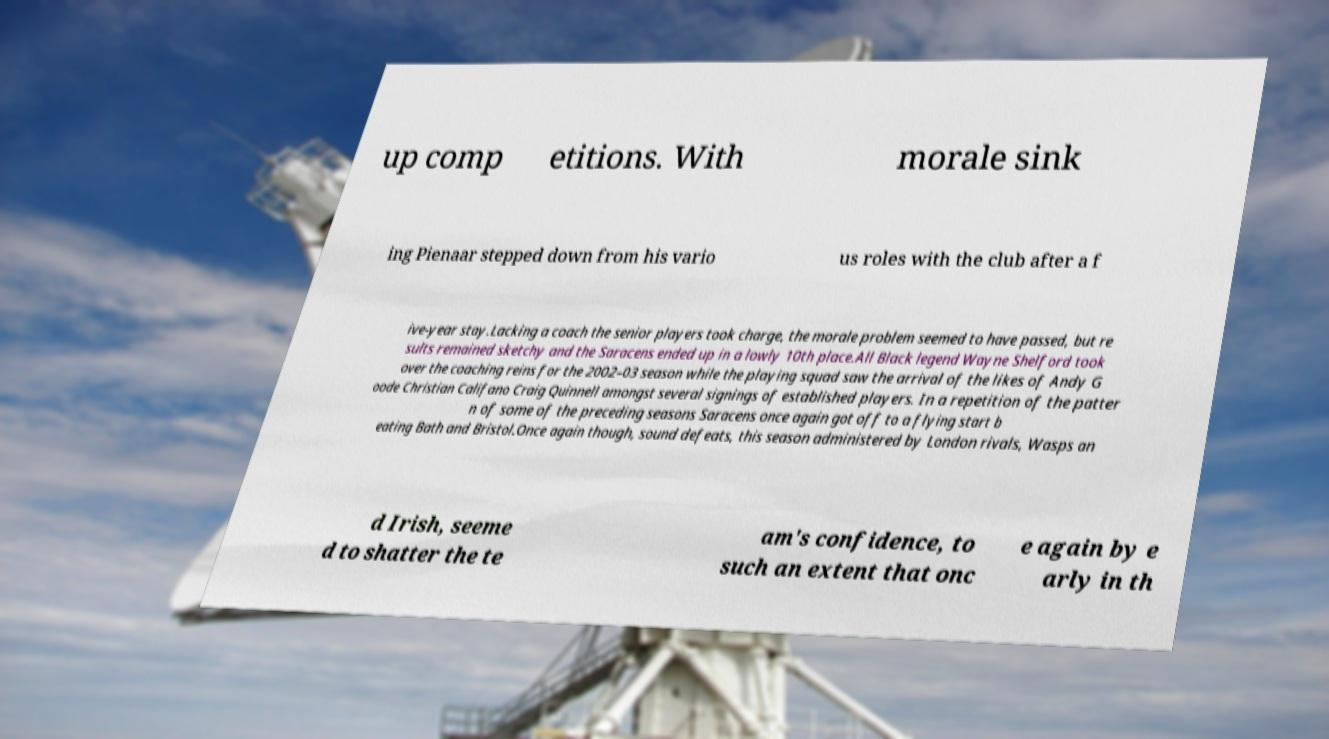Can you accurately transcribe the text from the provided image for me? up comp etitions. With morale sink ing Pienaar stepped down from his vario us roles with the club after a f ive-year stay.Lacking a coach the senior players took charge, the morale problem seemed to have passed, but re sults remained sketchy and the Saracens ended up in a lowly 10th place.All Black legend Wayne Shelford took over the coaching reins for the 2002–03 season while the playing squad saw the arrival of the likes of Andy G oode Christian Califano Craig Quinnell amongst several signings of established players. In a repetition of the patter n of some of the preceding seasons Saracens once again got off to a flying start b eating Bath and Bristol.Once again though, sound defeats, this season administered by London rivals, Wasps an d Irish, seeme d to shatter the te am's confidence, to such an extent that onc e again by e arly in th 